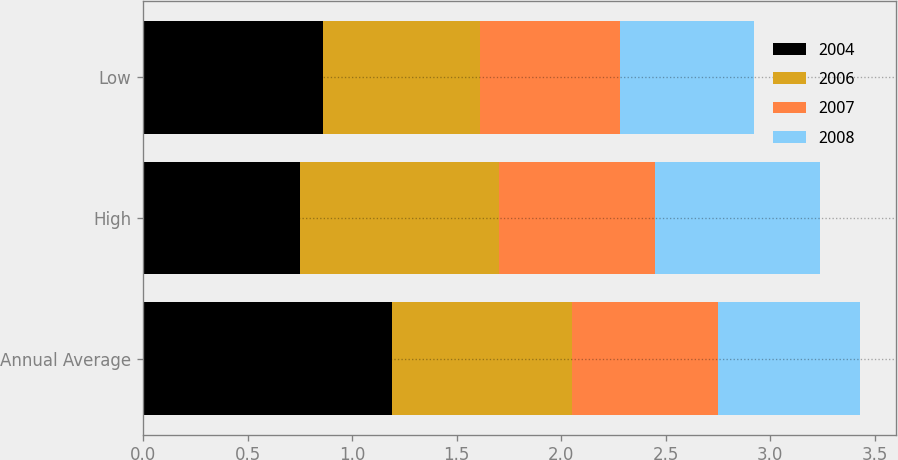Convert chart. <chart><loc_0><loc_0><loc_500><loc_500><stacked_bar_chart><ecel><fcel>Annual Average<fcel>High<fcel>Low<nl><fcel>2004<fcel>1.19<fcel>0.75<fcel>0.86<nl><fcel>2006<fcel>0.86<fcel>0.95<fcel>0.75<nl><fcel>2007<fcel>0.7<fcel>0.75<fcel>0.67<nl><fcel>2008<fcel>0.68<fcel>0.79<fcel>0.64<nl></chart> 